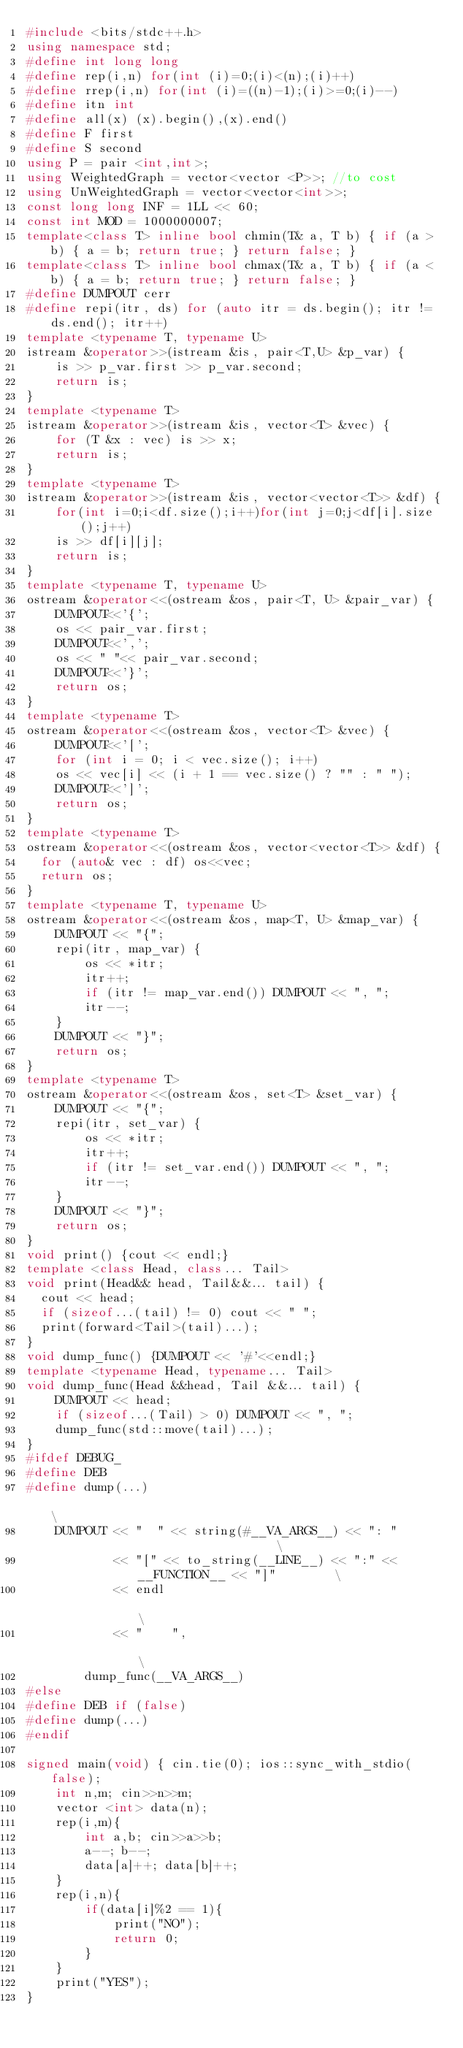<code> <loc_0><loc_0><loc_500><loc_500><_C++_>#include <bits/stdc++.h>
using namespace std;
#define int long long
#define rep(i,n) for(int (i)=0;(i)<(n);(i)++)
#define rrep(i,n) for(int (i)=((n)-1);(i)>=0;(i)--)
#define itn int
#define all(x) (x).begin(),(x).end()
#define F first
#define S second
using P = pair <int,int>;
using WeightedGraph = vector<vector <P>>; //to cost
using UnWeightedGraph = vector<vector<int>>;
const long long INF = 1LL << 60;
const int MOD = 1000000007;
template<class T> inline bool chmin(T& a, T b) { if (a > b) { a = b; return true; } return false; }
template<class T> inline bool chmax(T& a, T b) { if (a < b) { a = b; return true; } return false; }
#define DUMPOUT cerr
#define repi(itr, ds) for (auto itr = ds.begin(); itr != ds.end(); itr++)
template <typename T, typename U>
istream &operator>>(istream &is, pair<T,U> &p_var) {
    is >> p_var.first >> p_var.second;
    return is;
}
template <typename T>
istream &operator>>(istream &is, vector<T> &vec) {
    for (T &x : vec) is >> x;
    return is;
}
template <typename T>
istream &operator>>(istream &is, vector<vector<T>> &df) {
    for(int i=0;i<df.size();i++)for(int j=0;j<df[i].size();j++)
    is >> df[i][j];
    return is;
}
template <typename T, typename U>
ostream &operator<<(ostream &os, pair<T, U> &pair_var) {
    DUMPOUT<<'{';
    os << pair_var.first;
    DUMPOUT<<',';
    os << " "<< pair_var.second;
    DUMPOUT<<'}';
    return os;
}
template <typename T>
ostream &operator<<(ostream &os, vector<T> &vec) {
    DUMPOUT<<'[';
    for (int i = 0; i < vec.size(); i++) 
    os << vec[i] << (i + 1 == vec.size() ? "" : " ");
    DUMPOUT<<']';
    return os;
}
template <typename T>
ostream &operator<<(ostream &os, vector<vector<T>> &df) {
  for (auto& vec : df) os<<vec;
  return os;
}
template <typename T, typename U>
ostream &operator<<(ostream &os, map<T, U> &map_var) {
    DUMPOUT << "{";
    repi(itr, map_var) {
        os << *itr;
        itr++;
        if (itr != map_var.end()) DUMPOUT << ", ";
        itr--;
    }
    DUMPOUT << "}";
    return os;
}
template <typename T>
ostream &operator<<(ostream &os, set<T> &set_var) {
    DUMPOUT << "{";
    repi(itr, set_var) {
        os << *itr;
        itr++;
        if (itr != set_var.end()) DUMPOUT << ", ";
        itr--;
    }
    DUMPOUT << "}";
    return os;
}
void print() {cout << endl;}
template <class Head, class... Tail>
void print(Head&& head, Tail&&... tail) {
  cout << head;
  if (sizeof...(tail) != 0) cout << " ";
  print(forward<Tail>(tail)...);
}
void dump_func() {DUMPOUT << '#'<<endl;}
template <typename Head, typename... Tail>
void dump_func(Head &&head, Tail &&... tail) {
    DUMPOUT << head;
    if (sizeof...(Tail) > 0) DUMPOUT << ", ";
    dump_func(std::move(tail)...);
}
#ifdef DEBUG_
#define DEB
#define dump(...)                                                              \
    DUMPOUT << "  " << string(#__VA_ARGS__) << ": "                            \
            << "[" << to_string(__LINE__) << ":" << __FUNCTION__ << "]"        \
            << endl                                                            \
            << "    ",                                                         \
        dump_func(__VA_ARGS__)
#else
#define DEB if (false)
#define dump(...)
#endif

signed main(void) { cin.tie(0); ios::sync_with_stdio(false);
    int n,m; cin>>n>>m;
    vector <int> data(n);
    rep(i,m){
        int a,b; cin>>a>>b;
        a--; b--;
        data[a]++; data[b]++;
    }
    rep(i,n){
        if(data[i]%2 == 1){
            print("NO");
            return 0;
        }
    }
    print("YES");
}
</code> 